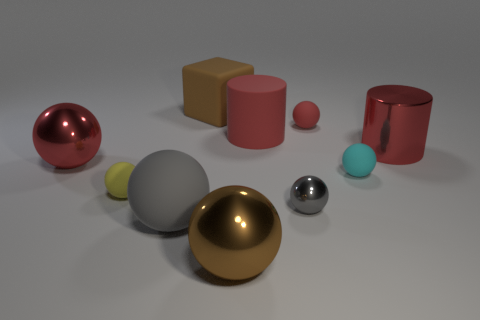What is the shape of the tiny rubber object that is both in front of the matte cylinder and to the right of the tiny gray ball?
Keep it short and to the point. Sphere. The cyan thing that is made of the same material as the big brown block is what shape?
Your answer should be compact. Sphere. There is a gray ball that is on the right side of the large gray thing; what material is it?
Your answer should be very brief. Metal. Is the size of the gray ball that is to the left of the big brown rubber block the same as the red thing that is left of the big brown cube?
Make the answer very short. Yes. What is the color of the large matte cylinder?
Give a very brief answer. Red. Is the shape of the brown object that is behind the big red metal cylinder the same as  the small yellow object?
Ensure brevity in your answer.  No. What is the material of the large gray object?
Provide a succinct answer. Rubber. What is the shape of the red matte object that is the same size as the block?
Keep it short and to the point. Cylinder. Is there a big metal thing that has the same color as the big block?
Your response must be concise. Yes. Does the tiny metallic object have the same color as the tiny matte sphere behind the red metallic cylinder?
Give a very brief answer. No. 